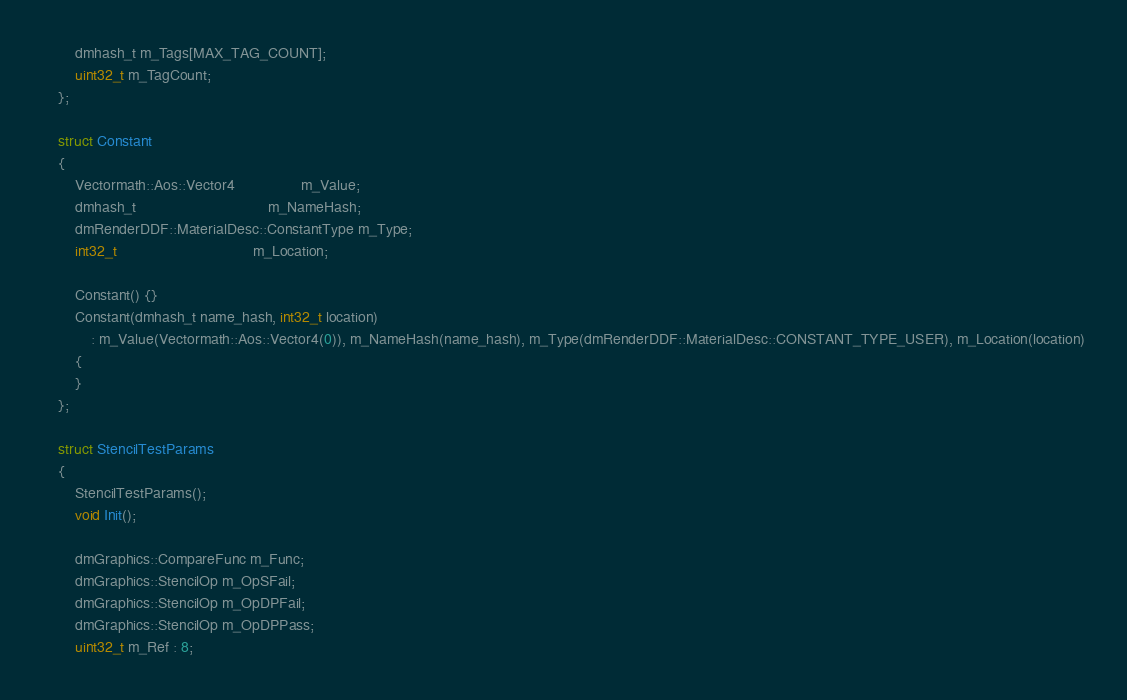<code> <loc_0><loc_0><loc_500><loc_500><_C_>        dmhash_t m_Tags[MAX_TAG_COUNT];
        uint32_t m_TagCount;
    };

    struct Constant
    {
        Vectormath::Aos::Vector4                m_Value;
        dmhash_t                                m_NameHash;
        dmRenderDDF::MaterialDesc::ConstantType m_Type;
        int32_t                                 m_Location;

        Constant() {}
        Constant(dmhash_t name_hash, int32_t location)
            : m_Value(Vectormath::Aos::Vector4(0)), m_NameHash(name_hash), m_Type(dmRenderDDF::MaterialDesc::CONSTANT_TYPE_USER), m_Location(location)
        {
        }
    };

    struct StencilTestParams
    {
        StencilTestParams();
        void Init();

        dmGraphics::CompareFunc m_Func;
        dmGraphics::StencilOp m_OpSFail;
        dmGraphics::StencilOp m_OpDPFail;
        dmGraphics::StencilOp m_OpDPPass;
        uint32_t m_Ref : 8;</code> 